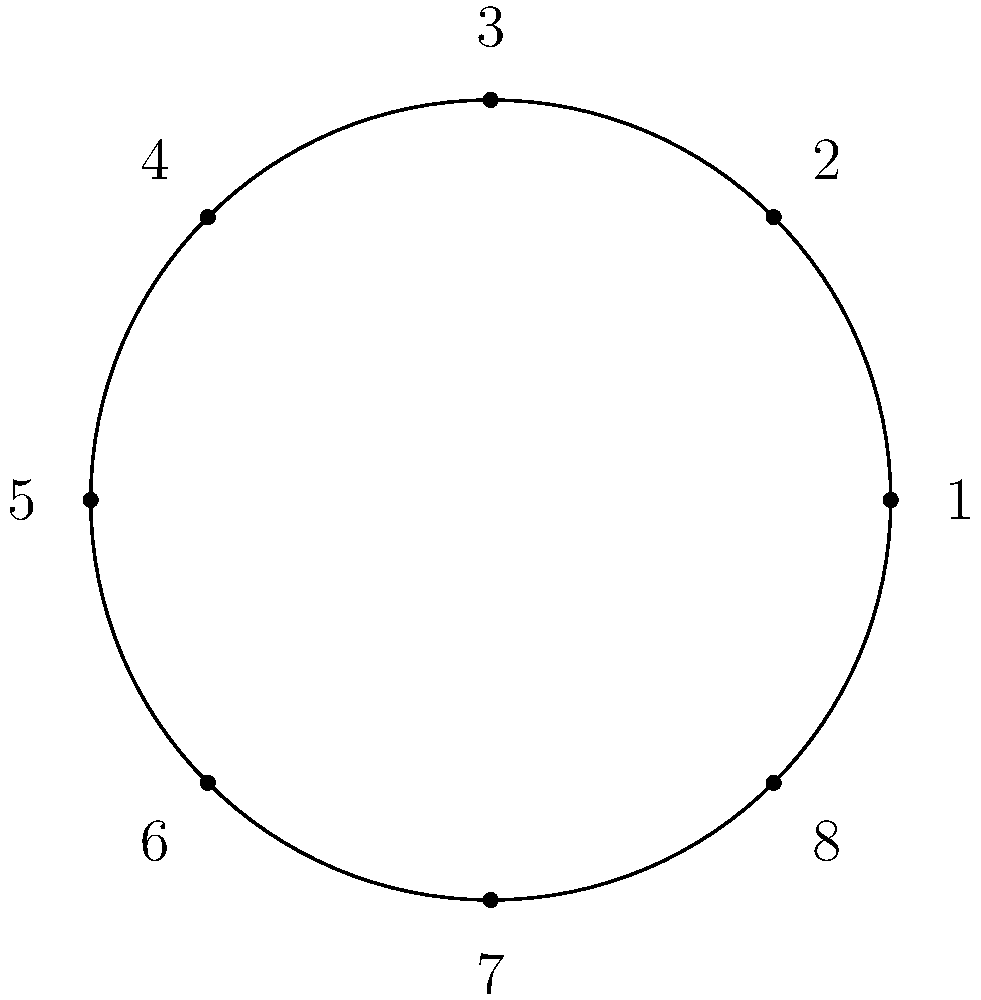In a high-stakes poker tournament at Casino Gran Madrid, you need to arrange 8 players around a circular table to minimize potential collusion. Players 1 and 5 are known friends, while players 3 and 7 are rivals. What is the maximum number of seats that can separate both pairs (friends and rivals) simultaneously? Let's approach this step-by-step:

1) We have 8 players numbered 1 to 8 in a circular arrangement.

2) For any pair of players, the maximum distance between them is 4 seats (half the table).

3) We need to maximize the distance for both pairs: (1,5) and (3,7).

4) Let's fix player 1's position and consider the options for player 5:
   - If 5 is directly opposite 1 (4 seats away), we have: 1-x-x-x-5-x-x-x-1
   - This leaves two options for placing 3 and 7:
     a) 1-3-x-x-5-x-x-7-1 (3 seats between 3 and 7)
     b) 1-7-x-x-5-x-x-3-1 (3 seats between 3 and 7)

5) We can't increase the distance between 3 and 7 without decreasing the distance between 1 and 5.

6) Therefore, the maximum number of seats that can separate both pairs simultaneously is 3.
Answer: 3 seats 